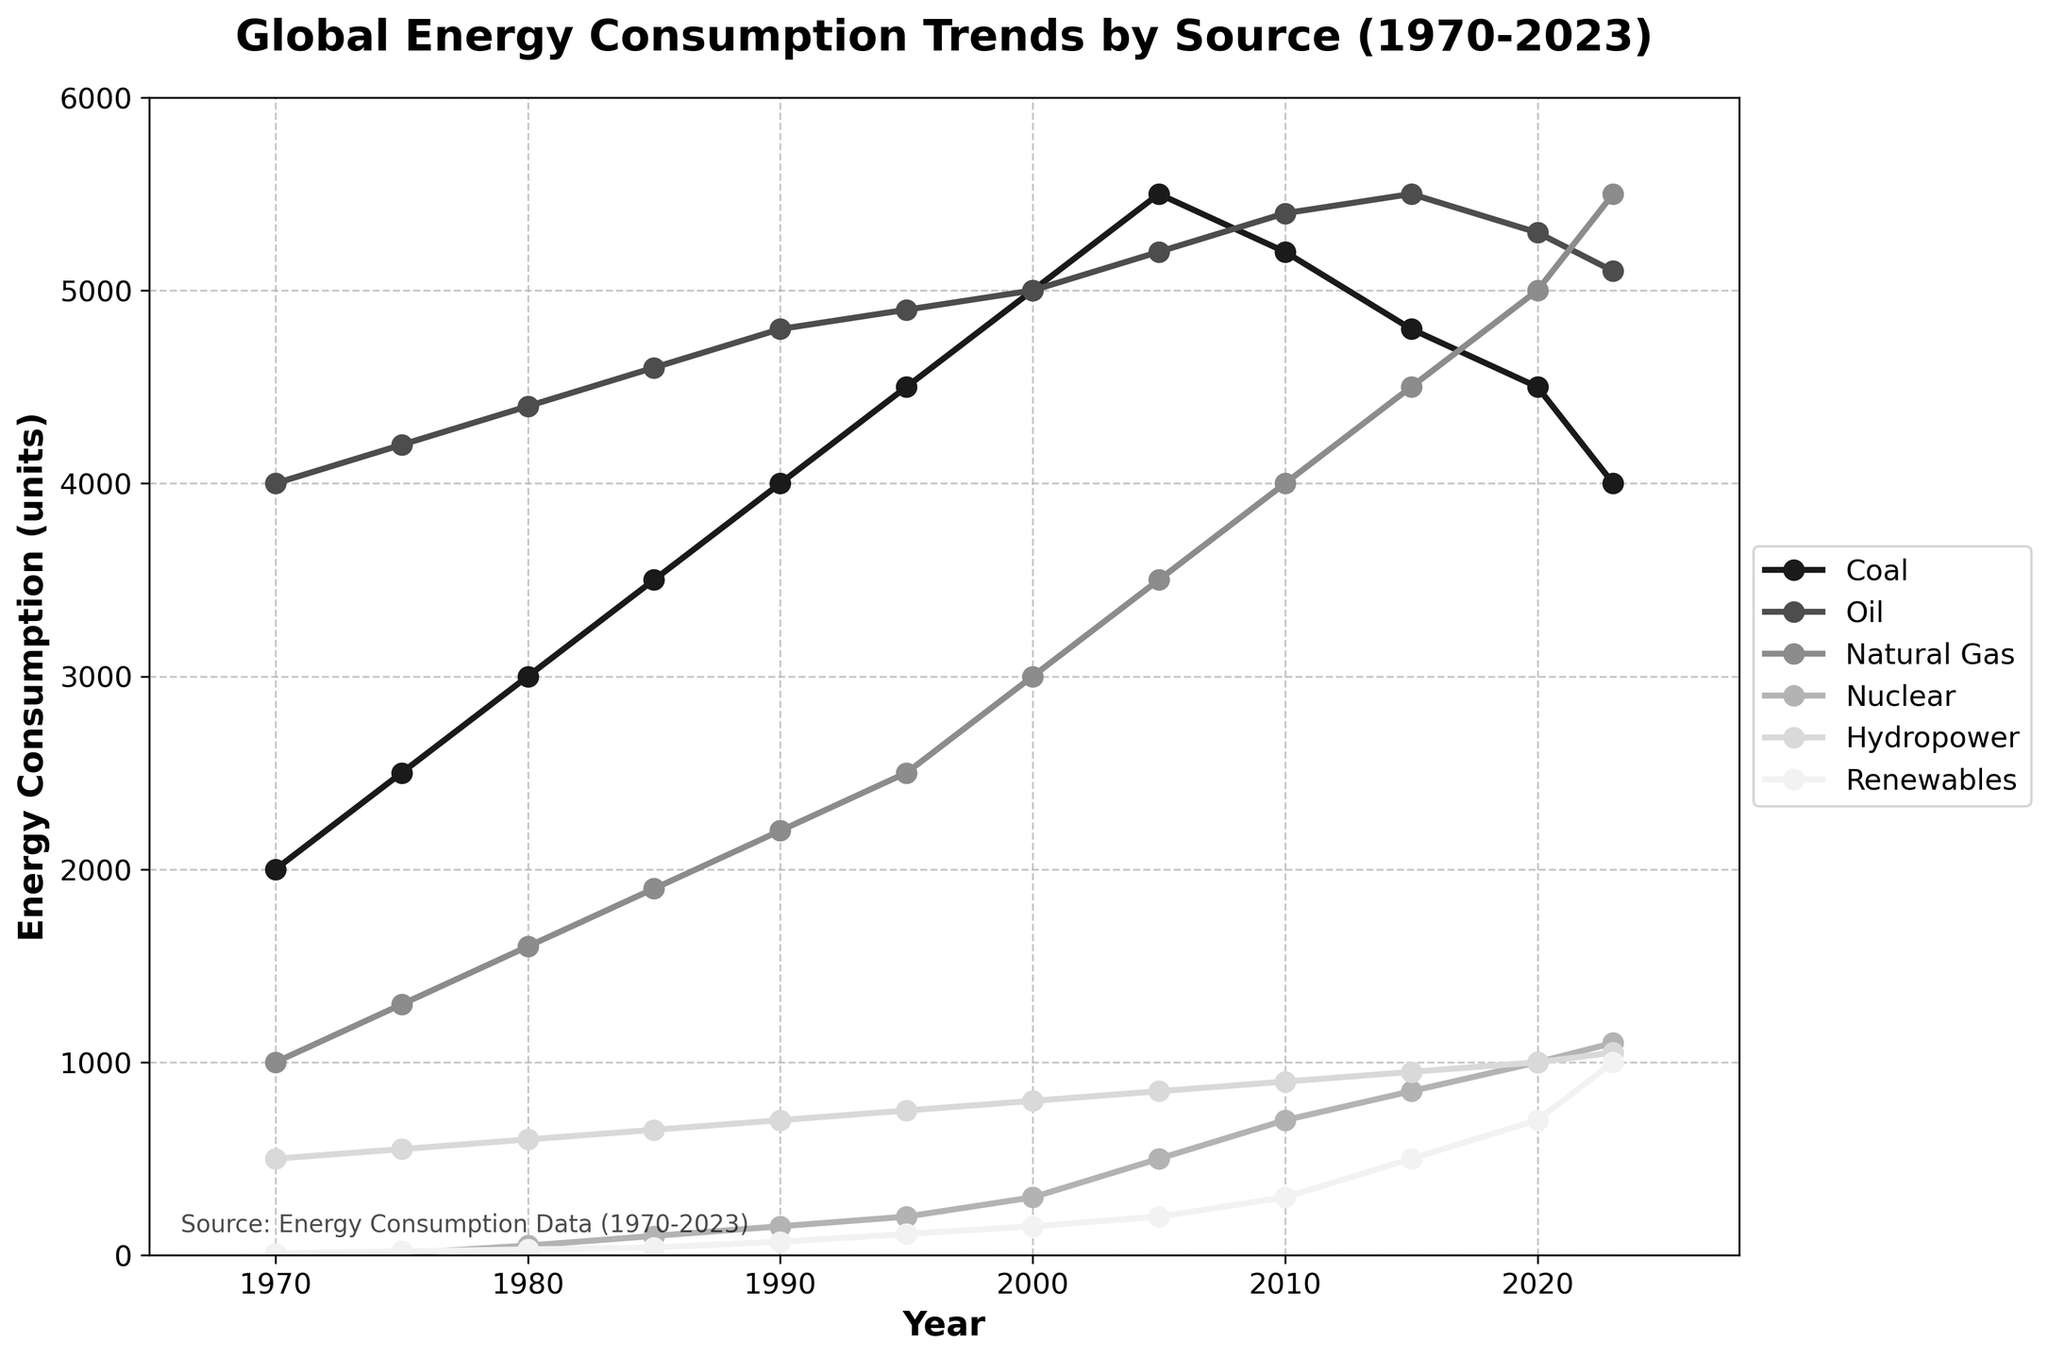What is the title of the plot? The title of the plot is located at the top of the figure. By observing it, one can see it reads "Global Energy Consumption Trends by Source (1970-2023)"
Answer: Global Energy Consumption Trends by Source (1970-2023) Which energy source has the highest consumption in the year 2023? Look at the data points for the year 2023 across all energy sources and compare their values. In 2023, Natural Gas has the highest value at 5500 units.
Answer: Natural Gas By how much did coal consumption increase from 1970 to 2023? Subtract the coal consumption in 1970 (2000 units) from the coal consumption in 2023 (4000 units). The increase is 4000 - 2000 = 2000 units.
Answer: 2000 units Which energy sources show a positive trend from 1970 to 2023? Evaluate each energy source's trend by comparing its initial value in 1970 to its final value in 2023. The sources with increasing values are Natural Gas, Nuclear, Hydropower, and Renewables.
Answer: Natural Gas, Nuclear, Hydropower, Renewables What are the total energy consumption units in the year 1990? Sum the consumption values of all sources in 1990. The total is 4000 (Coal) + 4800 (Oil) + 2200 (Natural Gas) + 150 (Nuclear) + 700 (Hydropower) + 70 (Renewables) = 11920 units.
Answer: 11920 units Which energy source had the steepest increase in consumption from 2000 to 2023? Calculate the difference in consumption for each energy source from 2000 to 2023 and compare the differences. Renewables had the steepest increase with a change of 1000 - 150 = 850 units.
Answer: Renewables How many data points are there in the plot for each energy source? Since the data spans from 1970 to 2023, with each entry representing a year, count the number of years listed. There are 12 data points for each energy source.
Answer: 12 data points When did renewable energy exceed 500 units in consumption? Examine the consumption values for Renewables year by year. Renewables exceeded 500 units in 2015 for the first time.
Answer: 2015 Which energy source had the most stable consumption trend from 1970 to 2023? Look for the energy source whose trend line exhibits the least variation over time. Hydropower presents the most stable trend, showing a relatively steady increase.
Answer: Hydropower 